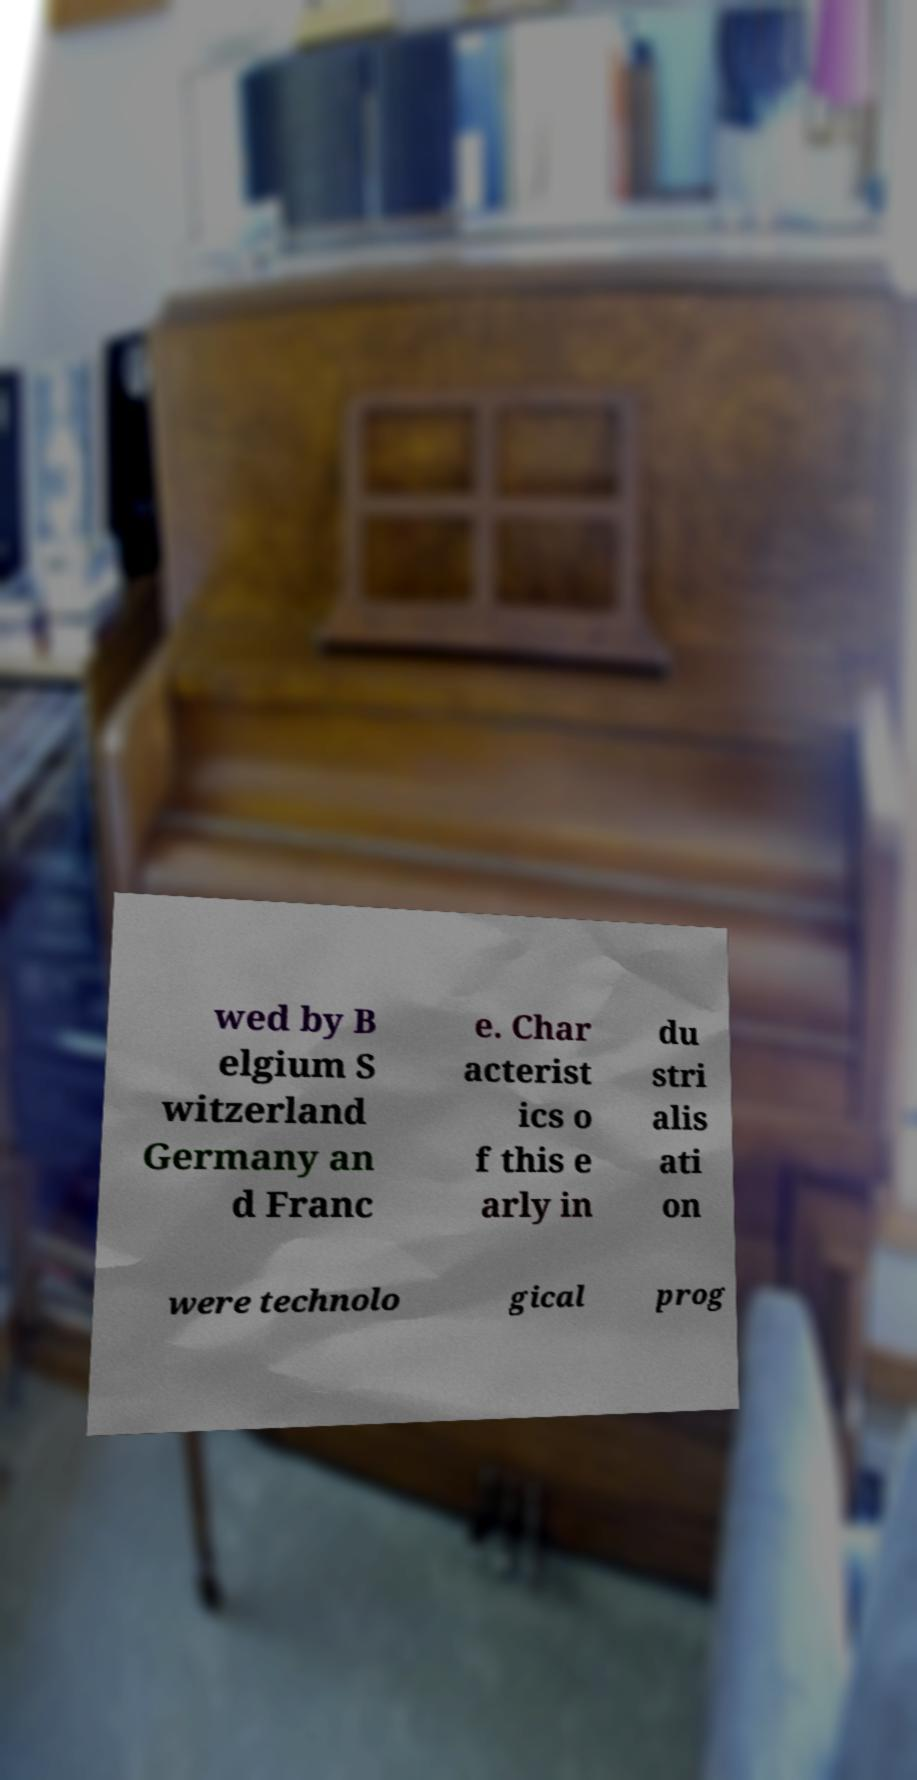Could you assist in decoding the text presented in this image and type it out clearly? wed by B elgium S witzerland Germany an d Franc e. Char acterist ics o f this e arly in du stri alis ati on were technolo gical prog 